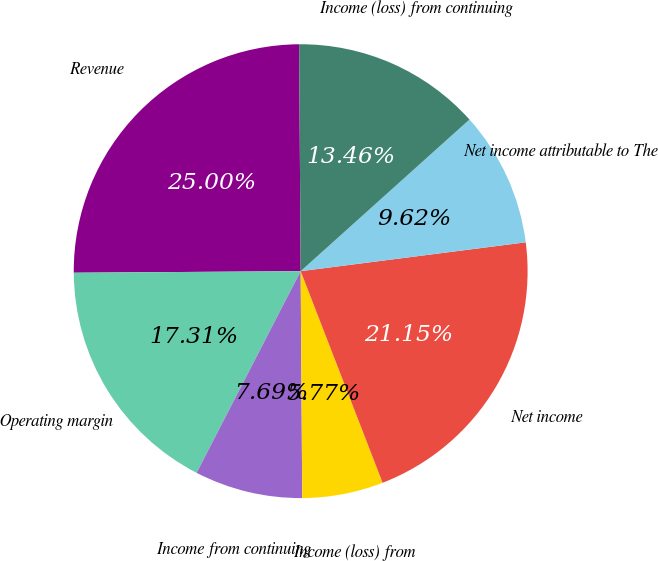<chart> <loc_0><loc_0><loc_500><loc_500><pie_chart><fcel>Revenue<fcel>Operating margin<fcel>Income from continuing<fcel>Income (loss) from<fcel>Net income<fcel>Net income attributable to The<fcel>Income (loss) from continuing<nl><fcel>25.0%<fcel>17.31%<fcel>7.69%<fcel>5.77%<fcel>21.15%<fcel>9.62%<fcel>13.46%<nl></chart> 